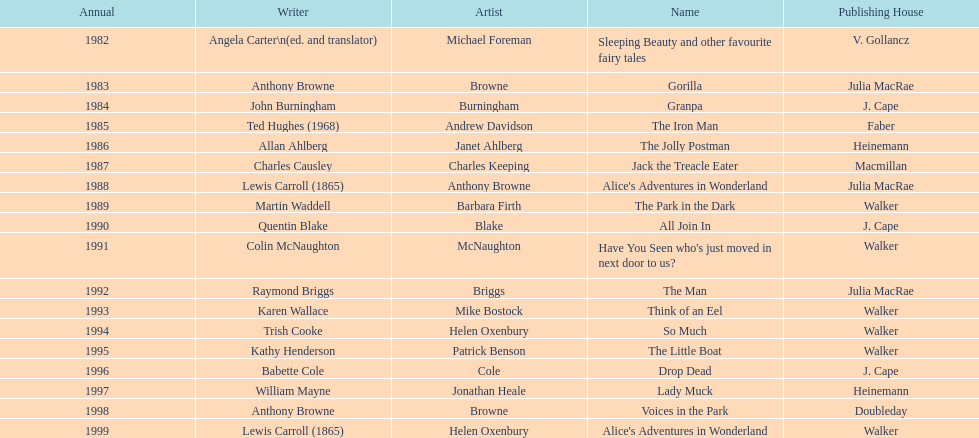Which author wrote the first award winner? Angela Carter. 